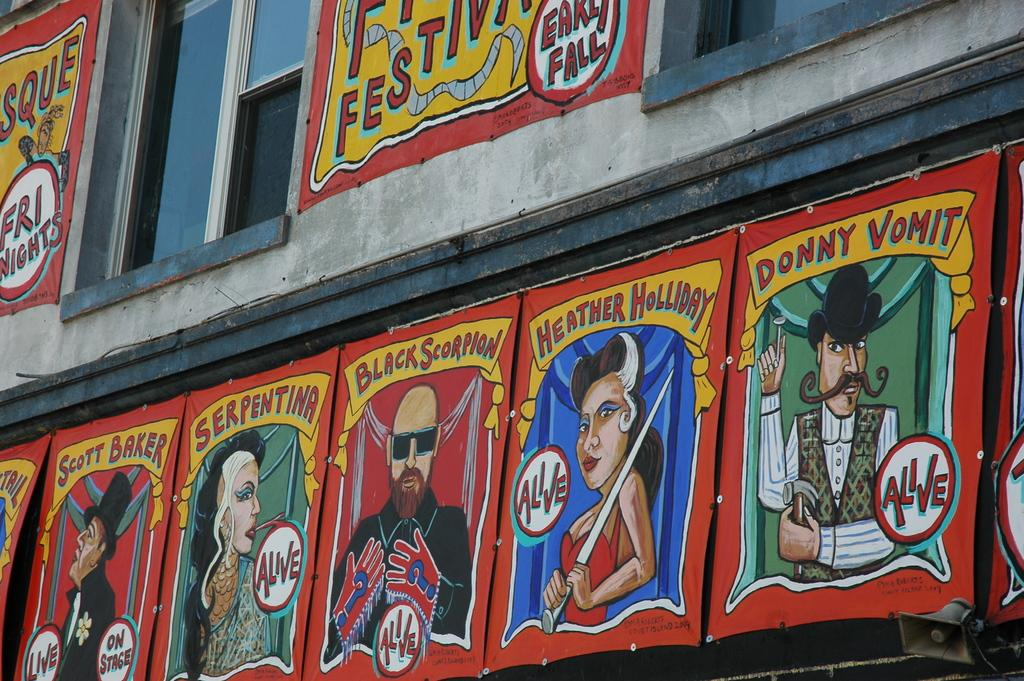What type of structure is visible in the image? There is a building in the image. What feature can be seen on the building? The building has windows. Are there any additional items attached to the building? Yes, there are posters attached to the building. What object is located in the bottom right corner of the image? There is a megaphone in the bottom right corner of the image. How many feet are visible on the building in the image? There are no feet visible on the building in the image. Can you describe the material of the posters attached to the building? The provided facts do not mention the material of the posters, so it cannot be determined from the image. 